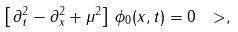<formula> <loc_0><loc_0><loc_500><loc_500>\left [ \, \partial _ { t } ^ { 2 } - \partial _ { x } ^ { 2 } + \mu ^ { 2 } \right ] \, \phi _ { 0 } ( x , t ) = 0 \ > ,</formula> 